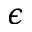<formula> <loc_0><loc_0><loc_500><loc_500>\epsilon</formula> 